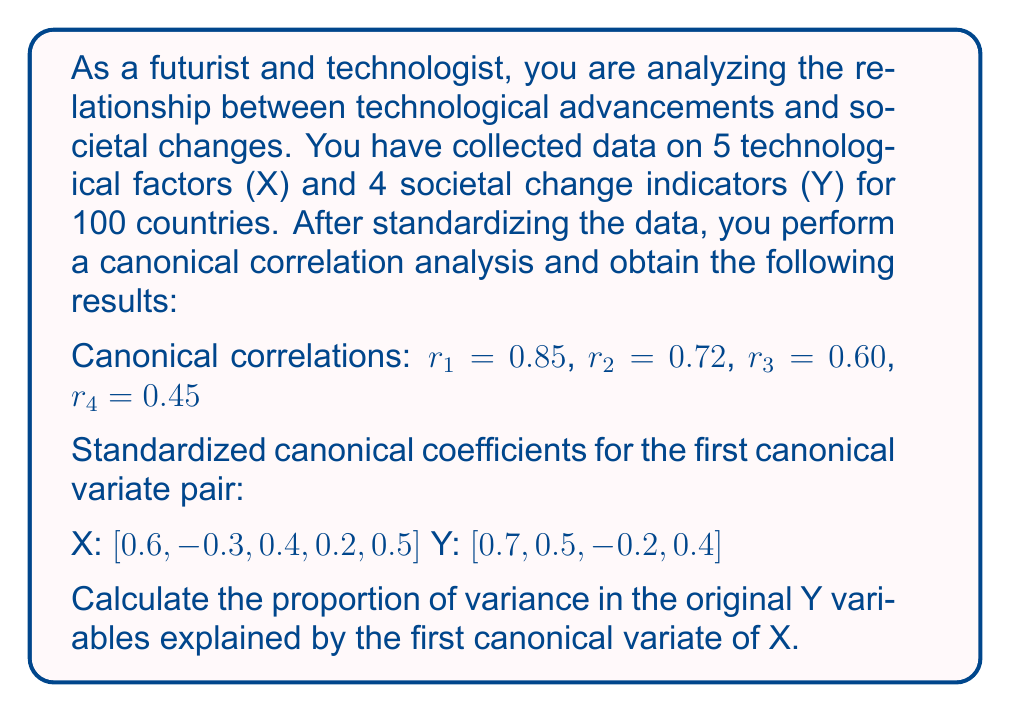Solve this math problem. To solve this problem, we'll follow these steps:

1) First, recall that the proportion of variance explained is calculated as:

   $\text{Proportion} = r_1^2 \times \text{average squared canonical loading}$

2) We need to calculate the average squared canonical loading for Y. The canonical loadings are the correlations between the original variables and their canonical variates.

3) For standardized data, the canonical loadings are equal to the product of the canonical coefficients and the canonical correlation. So, for each Y variable:

   $\text{loading}_i = r_1 \times \text{coefficient}_i$

4) Calculate the loadings:
   $\text{loading}_1 = 0.85 \times 0.7 = 0.595$
   $\text{loading}_2 = 0.85 \times 0.5 = 0.425$
   $\text{loading}_3 = 0.85 \times (-0.2) = -0.17$
   $\text{loading}_4 = 0.85 \times 0.4 = 0.34$

5) Square each loading:
   $0.595^2 = 0.354025$
   $0.425^2 = 0.180625$
   $(-0.17)^2 = 0.0289$
   $0.34^2 = 0.1156$

6) Calculate the average of these squared loadings:
   $\text{average} = (0.354025 + 0.180625 + 0.0289 + 0.1156) / 4 = 0.1697875$

7) Finally, multiply by $r_1^2$:
   $\text{Proportion} = 0.85^2 \times 0.1697875 = 0.7225 \times 0.1697875 = 0.12267$

Therefore, the proportion of variance in the original Y variables explained by the first canonical variate of X is approximately 0.12267 or 12.27%.
Answer: 0.12267 (or 12.27%) 